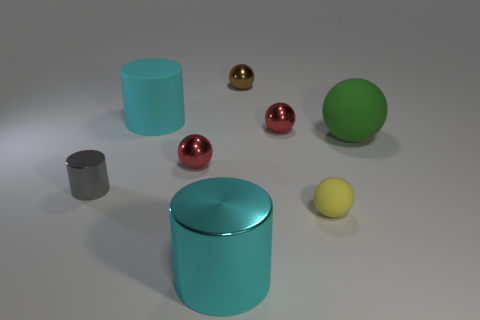There is a big object that is both behind the gray object and left of the brown thing; what is it made of?
Provide a short and direct response. Rubber. Is there any other thing of the same color as the tiny matte object?
Your answer should be very brief. No. What material is the big ball that is behind the small gray cylinder?
Ensure brevity in your answer.  Rubber. Do the metal object that is in front of the tiny cylinder and the cyan object that is behind the tiny cylinder have the same shape?
Ensure brevity in your answer.  Yes. Are there the same number of yellow spheres that are behind the rubber cylinder and red metal cubes?
Make the answer very short. Yes. What number of brown objects are made of the same material as the tiny yellow sphere?
Your response must be concise. 0. The tiny object that is the same material as the big sphere is what color?
Make the answer very short. Yellow. There is a brown metal sphere; is it the same size as the metallic object that is to the left of the large cyan matte thing?
Your answer should be very brief. Yes. There is a big cyan metal thing; what shape is it?
Make the answer very short. Cylinder. How many tiny metal things are the same color as the large ball?
Give a very brief answer. 0. 